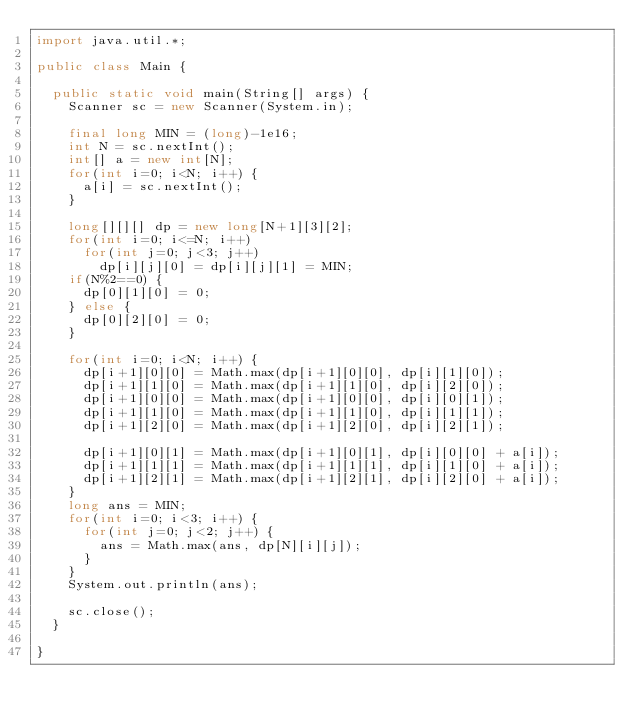<code> <loc_0><loc_0><loc_500><loc_500><_Java_>import java.util.*;

public class Main {
	
	public static void main(String[] args) {
		Scanner sc = new Scanner(System.in);
		
		final long MIN = (long)-1e16;
		int N = sc.nextInt();
		int[] a = new int[N];
		for(int i=0; i<N; i++) {
			a[i] = sc.nextInt();
		}

		long[][][] dp = new long[N+1][3][2];
		for(int i=0; i<=N; i++)
			for(int j=0; j<3; j++)
				dp[i][j][0] = dp[i][j][1] = MIN;
		if(N%2==0) {
			dp[0][1][0] = 0;
		} else {
			dp[0][2][0] = 0;
		}
		
		for(int i=0; i<N; i++) {
			dp[i+1][0][0] = Math.max(dp[i+1][0][0], dp[i][1][0]);
			dp[i+1][1][0] = Math.max(dp[i+1][1][0], dp[i][2][0]);
			dp[i+1][0][0] = Math.max(dp[i+1][0][0], dp[i][0][1]);
			dp[i+1][1][0] = Math.max(dp[i+1][1][0], dp[i][1][1]);
			dp[i+1][2][0] = Math.max(dp[i+1][2][0], dp[i][2][1]);

			dp[i+1][0][1] = Math.max(dp[i+1][0][1], dp[i][0][0] + a[i]);
			dp[i+1][1][1] = Math.max(dp[i+1][1][1], dp[i][1][0] + a[i]);
			dp[i+1][2][1] = Math.max(dp[i+1][2][1], dp[i][2][0] + a[i]);
		}
		long ans = MIN;
		for(int i=0; i<3; i++) {
			for(int j=0; j<2; j++) {
				ans = Math.max(ans, dp[N][i][j]);
			}
		}
		System.out.println(ans);
		
		sc.close();
	}

}
</code> 